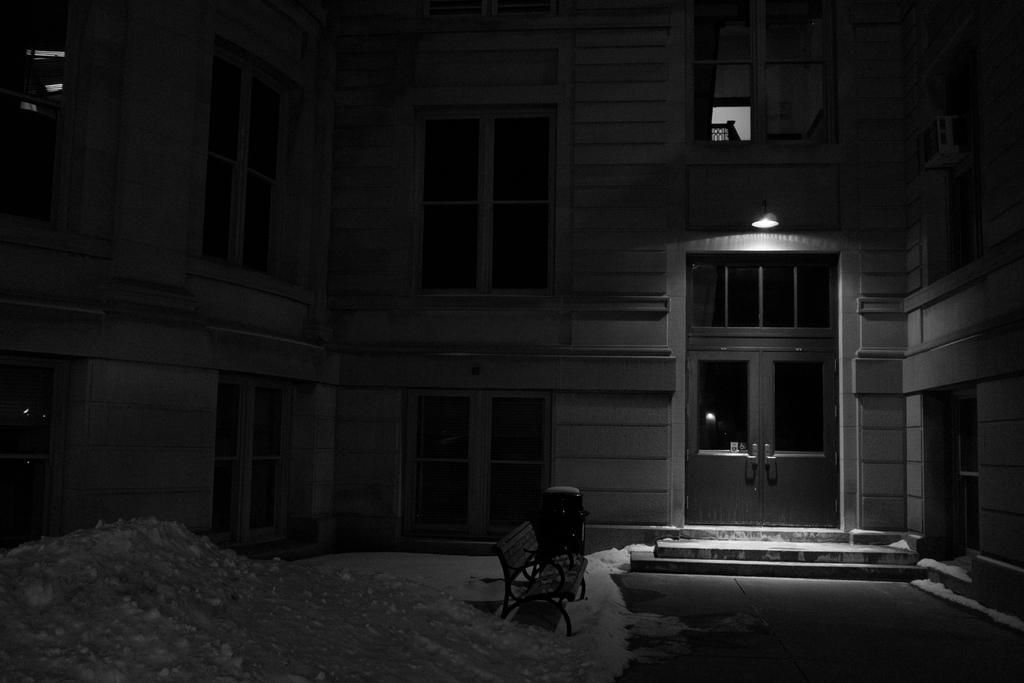Please provide a concise description of this image. In this image there is a building. At the bottom we can see a bench and there is snow. There are windows and we can see a door. 